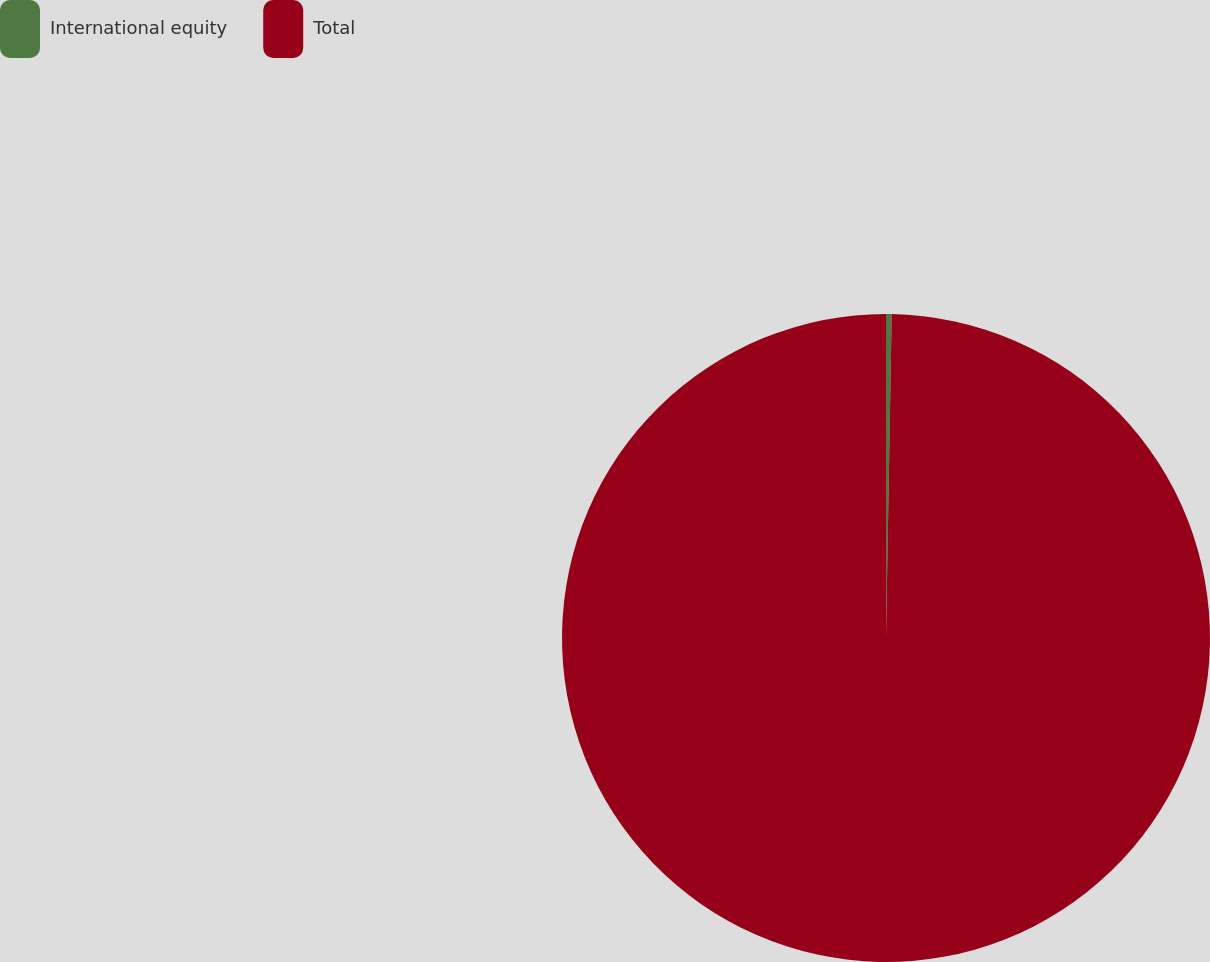Convert chart. <chart><loc_0><loc_0><loc_500><loc_500><pie_chart><fcel>International equity<fcel>Total<nl><fcel>0.28%<fcel>99.72%<nl></chart> 